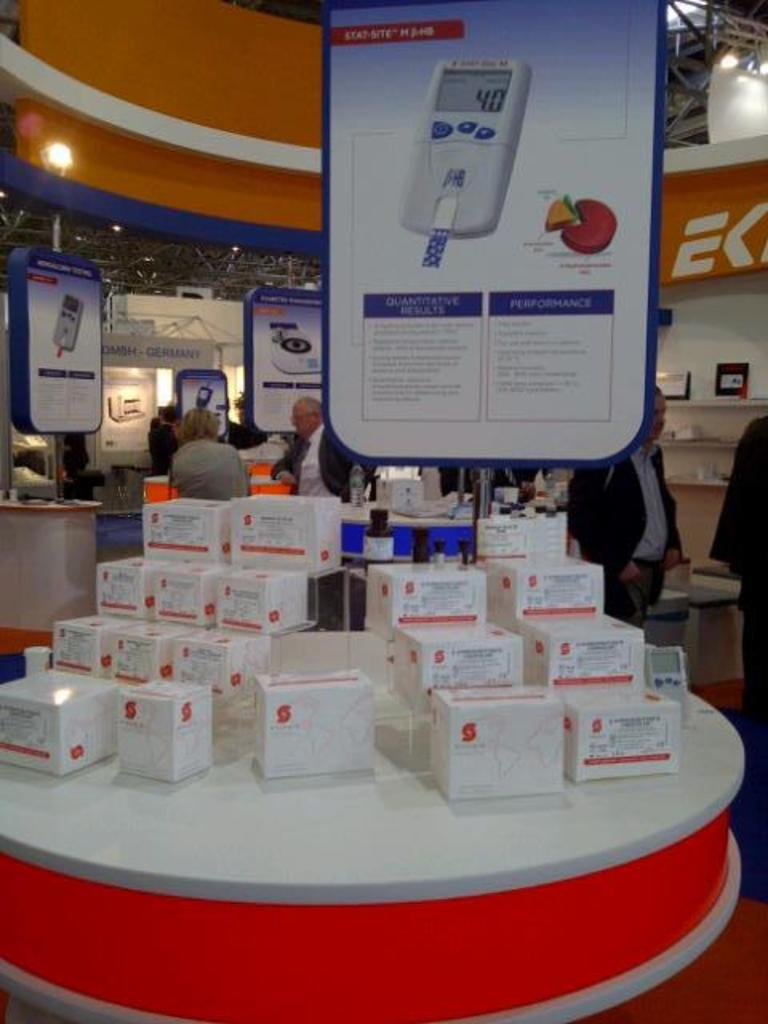<image>
Relay a brief, clear account of the picture shown. A store with lots of boxes for sale and an ad that talks about the devices performance. 